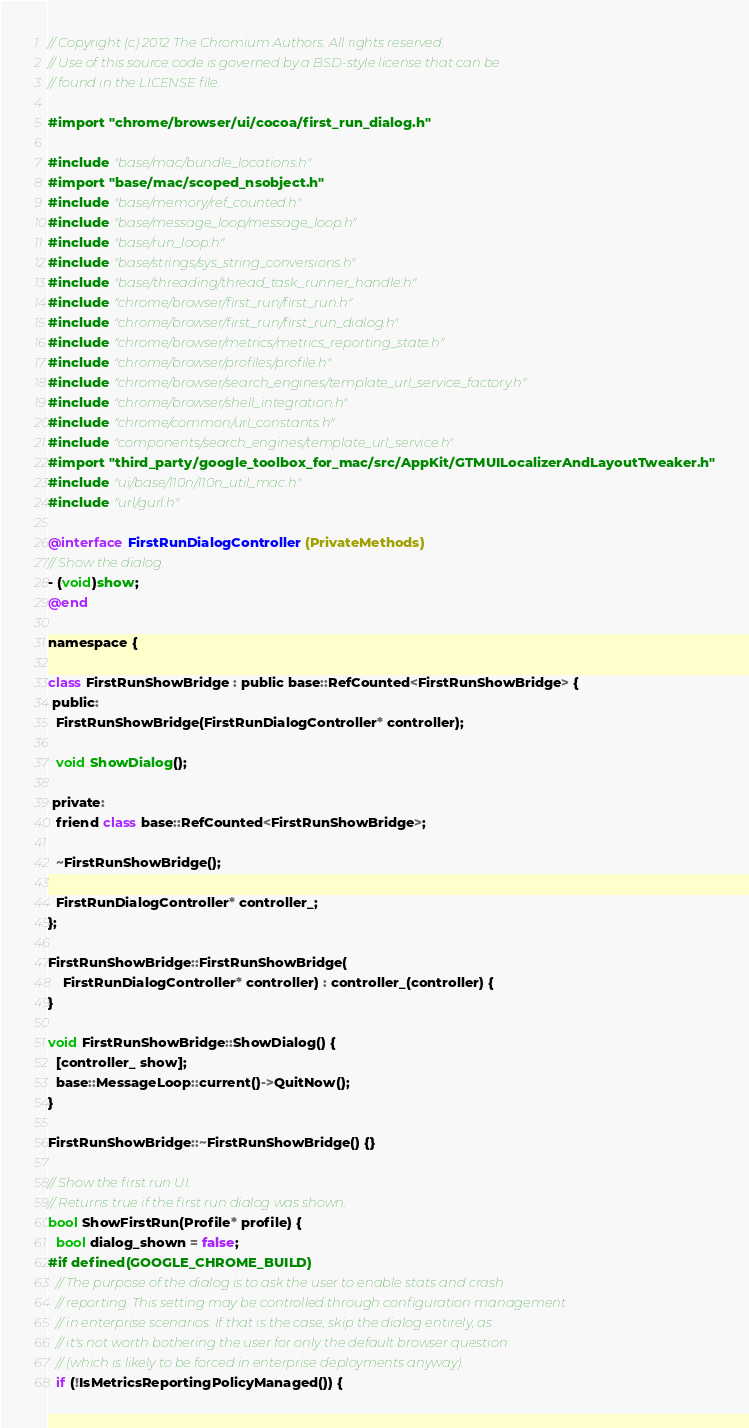<code> <loc_0><loc_0><loc_500><loc_500><_ObjectiveC_>// Copyright (c) 2012 The Chromium Authors. All rights reserved.
// Use of this source code is governed by a BSD-style license that can be
// found in the LICENSE file.

#import "chrome/browser/ui/cocoa/first_run_dialog.h"

#include "base/mac/bundle_locations.h"
#import "base/mac/scoped_nsobject.h"
#include "base/memory/ref_counted.h"
#include "base/message_loop/message_loop.h"
#include "base/run_loop.h"
#include "base/strings/sys_string_conversions.h"
#include "base/threading/thread_task_runner_handle.h"
#include "chrome/browser/first_run/first_run.h"
#include "chrome/browser/first_run/first_run_dialog.h"
#include "chrome/browser/metrics/metrics_reporting_state.h"
#include "chrome/browser/profiles/profile.h"
#include "chrome/browser/search_engines/template_url_service_factory.h"
#include "chrome/browser/shell_integration.h"
#include "chrome/common/url_constants.h"
#include "components/search_engines/template_url_service.h"
#import "third_party/google_toolbox_for_mac/src/AppKit/GTMUILocalizerAndLayoutTweaker.h"
#include "ui/base/l10n/l10n_util_mac.h"
#include "url/gurl.h"

@interface FirstRunDialogController (PrivateMethods)
// Show the dialog.
- (void)show;
@end

namespace {

class FirstRunShowBridge : public base::RefCounted<FirstRunShowBridge> {
 public:
  FirstRunShowBridge(FirstRunDialogController* controller);

  void ShowDialog();

 private:
  friend class base::RefCounted<FirstRunShowBridge>;

  ~FirstRunShowBridge();

  FirstRunDialogController* controller_;
};

FirstRunShowBridge::FirstRunShowBridge(
    FirstRunDialogController* controller) : controller_(controller) {
}

void FirstRunShowBridge::ShowDialog() {
  [controller_ show];
  base::MessageLoop::current()->QuitNow();
}

FirstRunShowBridge::~FirstRunShowBridge() {}

// Show the first run UI.
// Returns true if the first run dialog was shown.
bool ShowFirstRun(Profile* profile) {
  bool dialog_shown = false;
#if defined(GOOGLE_CHROME_BUILD)
  // The purpose of the dialog is to ask the user to enable stats and crash
  // reporting. This setting may be controlled through configuration management
  // in enterprise scenarios. If that is the case, skip the dialog entirely, as
  // it's not worth bothering the user for only the default browser question
  // (which is likely to be forced in enterprise deployments anyway).
  if (!IsMetricsReportingPolicyManaged()) {</code> 